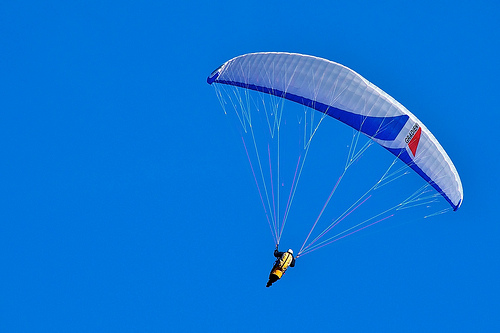What is on the kite? The kite has a cord attached to it, allowing the person to guide it through the air. 